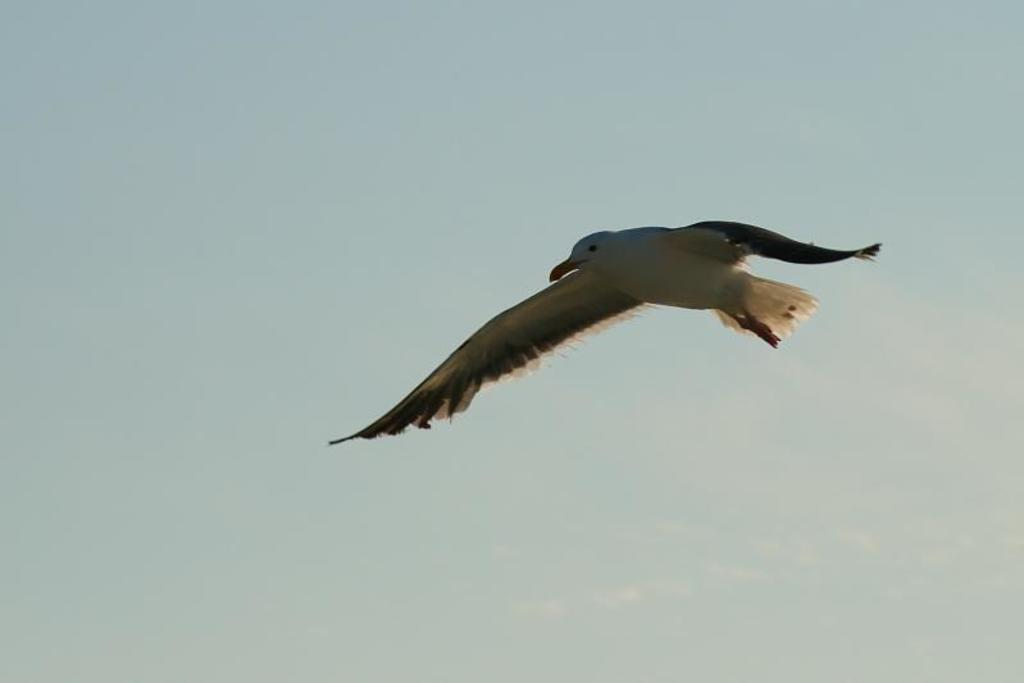What type of animal can be seen in the image? There is a bird in the image. What is the bird doing in the image? The bird is flying in the air. What color is the bird in the image? The bird is white in color. What can be seen in the background of the image? There is a sky visible in the background of the image. What type of dress is the bird wearing in the image? Birds do not wear dresses, so this question cannot be answered based on the image. 